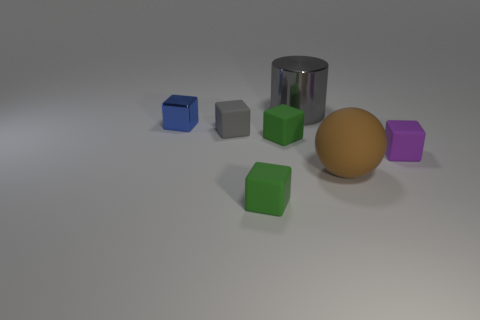How many purple things have the same shape as the big brown thing?
Offer a very short reply. 0. Is the size of the purple object the same as the cylinder that is left of the big matte sphere?
Your answer should be compact. No. What shape is the gray thing left of the metallic thing that is behind the blue thing?
Make the answer very short. Cube. Are there fewer big gray metal cylinders to the left of the tiny purple thing than small matte cubes?
Offer a very short reply. Yes. There is a tiny thing that is the same color as the big shiny cylinder; what shape is it?
Keep it short and to the point. Cube. What number of rubber things have the same size as the metal cube?
Offer a very short reply. 4. The big object that is to the right of the gray metal thing has what shape?
Keep it short and to the point. Sphere. Is the number of metal cubes less than the number of big brown shiny balls?
Your response must be concise. No. Is there anything else that is the same color as the metal cylinder?
Provide a short and direct response. Yes. How big is the gray rubber cube behind the tiny purple thing?
Your answer should be compact. Small. 